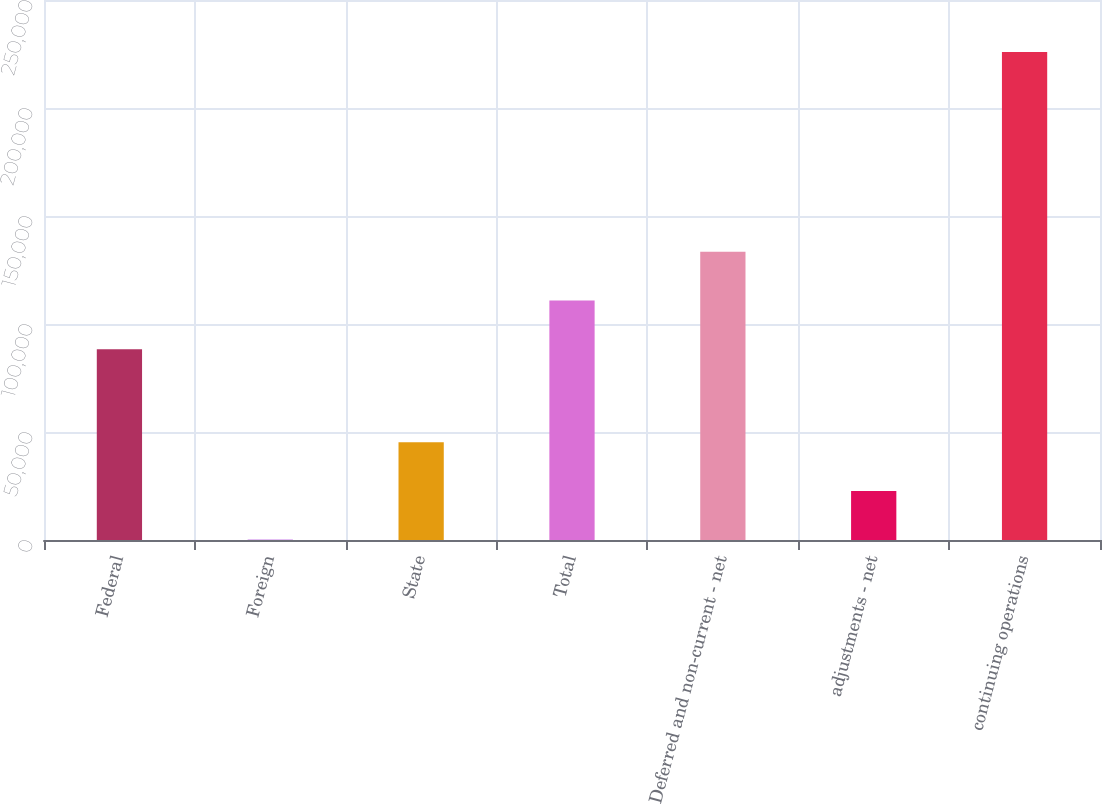Convert chart. <chart><loc_0><loc_0><loc_500><loc_500><bar_chart><fcel>Federal<fcel>Foreign<fcel>State<fcel>Total<fcel>Deferred and non-current - net<fcel>adjustments - net<fcel>continuing operations<nl><fcel>88291<fcel>101<fcel>45277<fcel>110879<fcel>133467<fcel>22689<fcel>225981<nl></chart> 